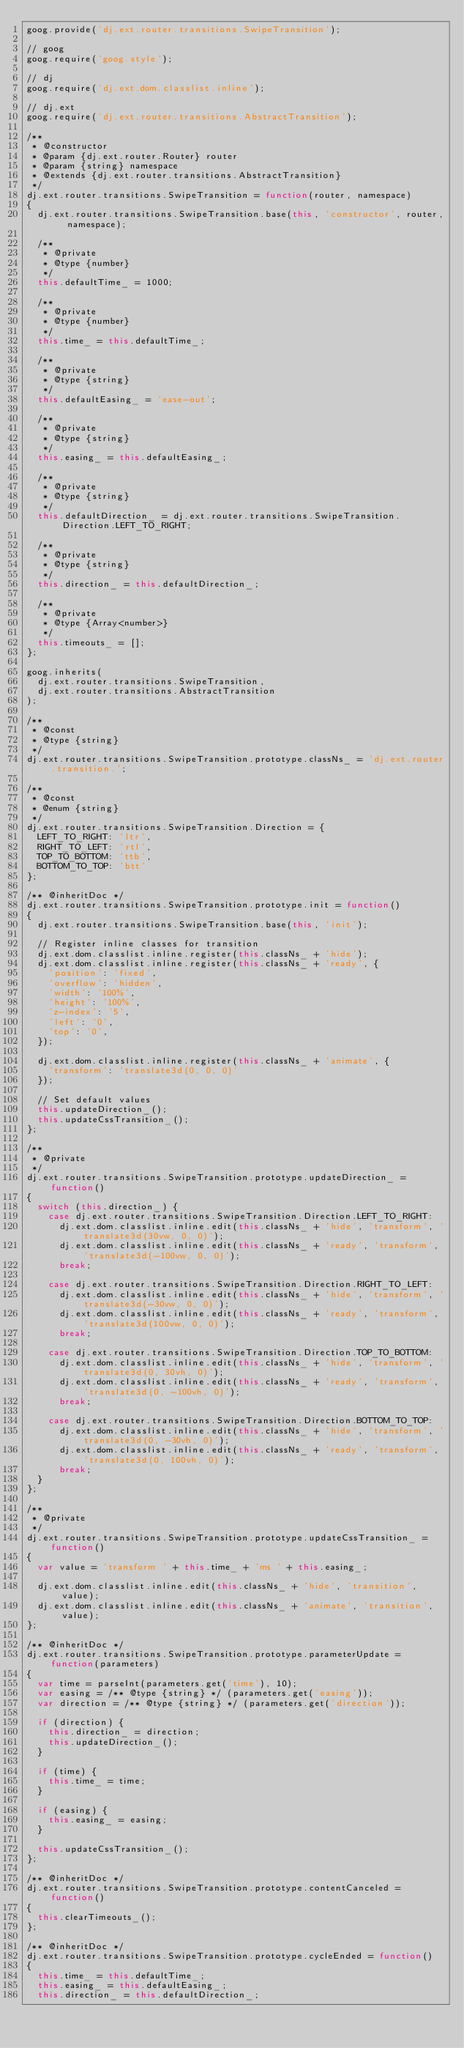<code> <loc_0><loc_0><loc_500><loc_500><_JavaScript_>goog.provide('dj.ext.router.transitions.SwipeTransition');

// goog
goog.require('goog.style');

// dj
goog.require('dj.ext.dom.classlist.inline');

// dj.ext
goog.require('dj.ext.router.transitions.AbstractTransition');

/**
 * @constructor
 * @param {dj.ext.router.Router} router
 * @param {string} namespace
 * @extends {dj.ext.router.transitions.AbstractTransition}
 */
dj.ext.router.transitions.SwipeTransition = function(router, namespace)
{
	dj.ext.router.transitions.SwipeTransition.base(this, 'constructor', router, namespace);

	/**
	 * @private
	 * @type {number}
	 */
	this.defaultTime_ = 1000;

	/**
	 * @private
	 * @type {number}
	 */
	this.time_ = this.defaultTime_;

	/**
	 * @private
	 * @type {string}
	 */
	this.defaultEasing_ = 'ease-out';

	/**
	 * @private
	 * @type {string}
	 */
	this.easing_ = this.defaultEasing_;

	/**
	 * @private
	 * @type {string}
	 */
	this.defaultDirection_ = dj.ext.router.transitions.SwipeTransition.Direction.LEFT_TO_RIGHT;

	/**
	 * @private
	 * @type {string}
	 */
	this.direction_ = this.defaultDirection_;

	/**
	 * @private
	 * @type {Array<number>}
	 */
	this.timeouts_ = [];
};

goog.inherits(
	dj.ext.router.transitions.SwipeTransition,
	dj.ext.router.transitions.AbstractTransition
);

/**
 * @const
 * @type {string}
 */
dj.ext.router.transitions.SwipeTransition.prototype.classNs_ = 'dj.ext.router.transition.';

/**
 * @const
 * @enum {string}
 */
dj.ext.router.transitions.SwipeTransition.Direction = {
	LEFT_TO_RIGHT: 'ltr',
	RIGHT_TO_LEFT: 'rtl',
	TOP_TO_BOTTOM: 'ttb',
	BOTTOM_TO_TOP: 'btt'
};

/** @inheritDoc */
dj.ext.router.transitions.SwipeTransition.prototype.init = function()
{
	dj.ext.router.transitions.SwipeTransition.base(this, 'init');

	// Register inline classes for transition
	dj.ext.dom.classlist.inline.register(this.classNs_ + 'hide');
	dj.ext.dom.classlist.inline.register(this.classNs_ + 'ready', {
		'position': 'fixed',
		'overflow': 'hidden',
		'width': '100%',
		'height': '100%',
		'z-index': '5',
		'left': '0',
		'top': '0',
	});

	dj.ext.dom.classlist.inline.register(this.classNs_ + 'animate', {
		'transform': 'translate3d(0, 0, 0)'
	});

	// Set default values
	this.updateDirection_();
	this.updateCssTransition_();
};

/**
 * @private
 */
dj.ext.router.transitions.SwipeTransition.prototype.updateDirection_ = function()
{
	switch (this.direction_) {
		case dj.ext.router.transitions.SwipeTransition.Direction.LEFT_TO_RIGHT:
			dj.ext.dom.classlist.inline.edit(this.classNs_ + 'hide', 'transform', 'translate3d(30vw, 0, 0)');
			dj.ext.dom.classlist.inline.edit(this.classNs_ + 'ready', 'transform', 'translate3d(-100vw, 0, 0)');
			break;

		case dj.ext.router.transitions.SwipeTransition.Direction.RIGHT_TO_LEFT:
			dj.ext.dom.classlist.inline.edit(this.classNs_ + 'hide', 'transform', 'translate3d(-30vw, 0, 0)');
			dj.ext.dom.classlist.inline.edit(this.classNs_ + 'ready', 'transform', 'translate3d(100vw, 0, 0)');
			break;

		case dj.ext.router.transitions.SwipeTransition.Direction.TOP_TO_BOTTOM:
			dj.ext.dom.classlist.inline.edit(this.classNs_ + 'hide', 'transform', 'translate3d(0, 30vh, 0)');
			dj.ext.dom.classlist.inline.edit(this.classNs_ + 'ready', 'transform', 'translate3d(0, -100vh, 0)');
			break;

		case dj.ext.router.transitions.SwipeTransition.Direction.BOTTOM_TO_TOP:
			dj.ext.dom.classlist.inline.edit(this.classNs_ + 'hide', 'transform', 'translate3d(0, -30vh, 0)');
			dj.ext.dom.classlist.inline.edit(this.classNs_ + 'ready', 'transform', 'translate3d(0, 100vh, 0)');
			break;
	}
};

/**
 * @private
 */
dj.ext.router.transitions.SwipeTransition.prototype.updateCssTransition_ = function()
{
	var value = 'transform ' + this.time_ + 'ms ' + this.easing_;

	dj.ext.dom.classlist.inline.edit(this.classNs_ + 'hide', 'transition', value);
	dj.ext.dom.classlist.inline.edit(this.classNs_ + 'animate', 'transition', value);
};

/** @inheritDoc */
dj.ext.router.transitions.SwipeTransition.prototype.parameterUpdate = function(parameters)
{
	var time = parseInt(parameters.get('time'), 10);
	var easing = /** @type {string} */ (parameters.get('easing'));
	var direction = /** @type {string} */ (parameters.get('direction'));

	if (direction) {
		this.direction_ = direction;
		this.updateDirection_();
	}

	if (time) {
		this.time_ = time;
	}

	if (easing) {
		this.easing_ = easing;
	}

	this.updateCssTransition_();
};

/** @inheritDoc */
dj.ext.router.transitions.SwipeTransition.prototype.contentCanceled = function()
{
	this.clearTimeouts_();
};

/** @inheritDoc */
dj.ext.router.transitions.SwipeTransition.prototype.cycleEnded = function()
{
	this.time_ = this.defaultTime_;
	this.easing_ = this.defaultEasing_;
	this.direction_ = this.defaultDirection_;
</code> 